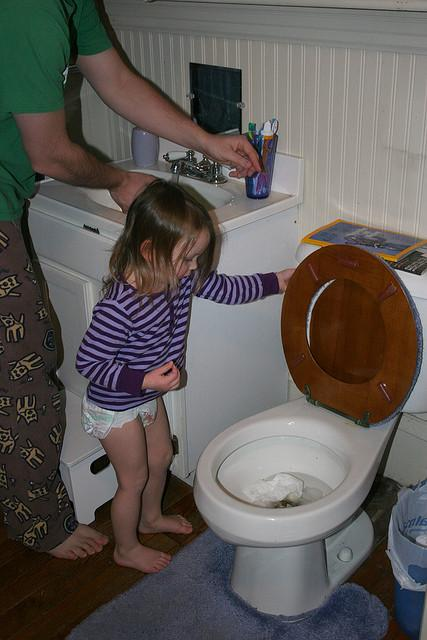What is the toddler about to do? flush toilet 